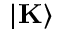Convert formula to latex. <formula><loc_0><loc_0><loc_500><loc_500>| K \rangle</formula> 